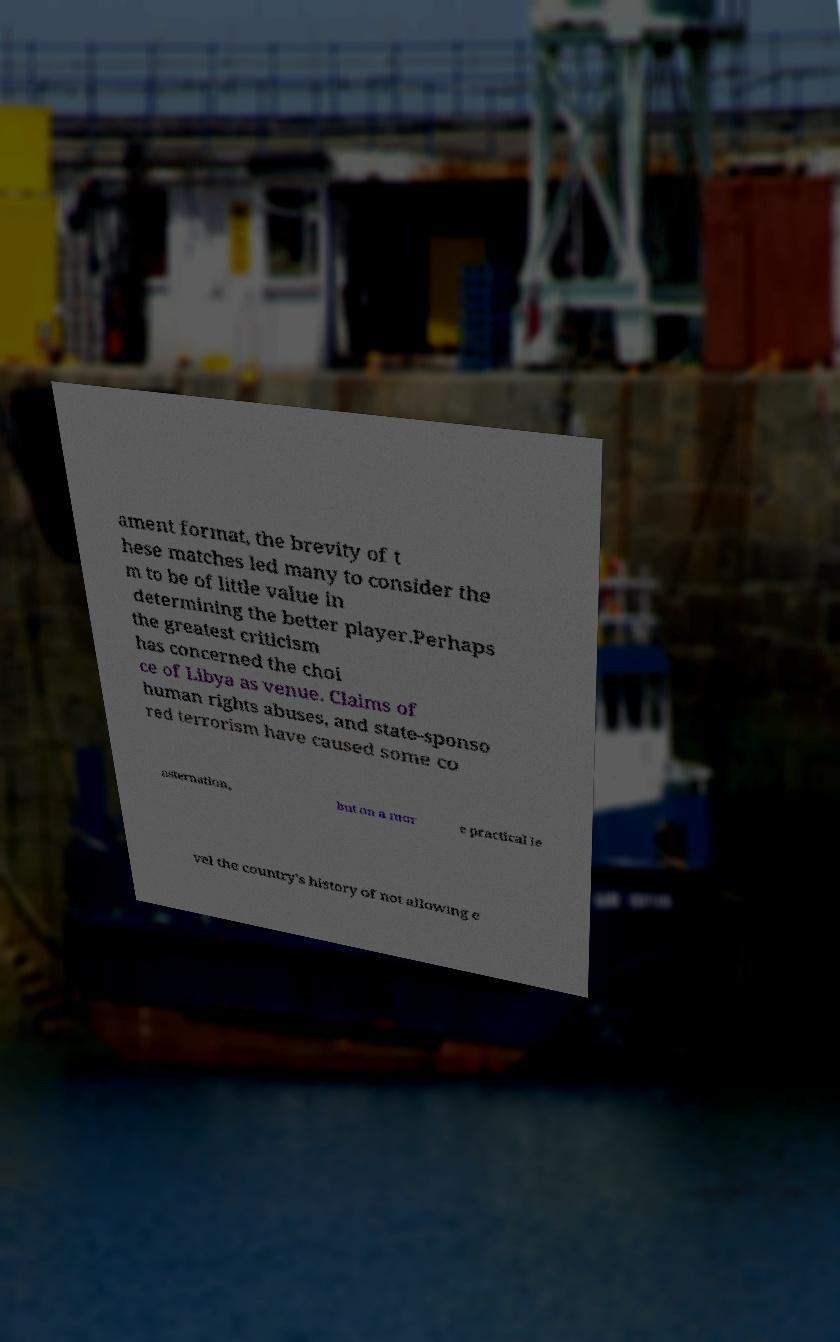For documentation purposes, I need the text within this image transcribed. Could you provide that? ament format, the brevity of t hese matches led many to consider the m to be of little value in determining the better player.Perhaps the greatest criticism has concerned the choi ce of Libya as venue. Claims of human rights abuses, and state-sponso red terrorism have caused some co nsternation, but on a mor e practical le vel the country's history of not allowing e 